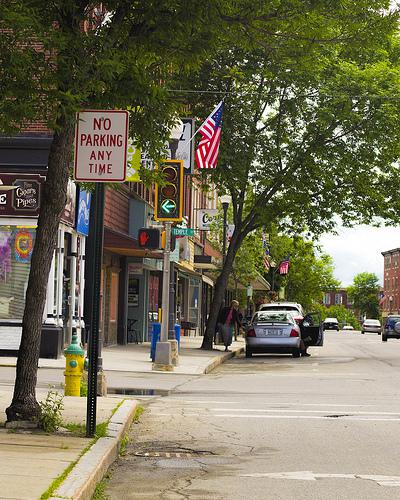Question: where was the picture taken?
Choices:
A. Under water.
B. Australia.
C. In a small town.
D. Paris.
Answer with the letter. Answer: C Question: what time of day is it?
Choices:
A. Lunch time.
B. Afternoon.
C. 4 o'clock.
D. Twilight.
Answer with the letter. Answer: B Question: what is lit up on the stop light?
Choices:
A. Red.
B. A green arrow.
C. Green.
D. Orange.
Answer with the letter. Answer: B Question: what does the sign say?
Choices:
A. No parking anytime.
B. Don't tread on me.
C. Caution.
D. Speed limit 75.
Answer with the letter. Answer: A Question: how many flags are hanging on the left side of the street?
Choices:
A. Four.
B. Three.
C. Five.
D. Six.
Answer with the letter. Answer: B Question: what is hanging over the car?
Choices:
A. Her arm.
B. A flag.
C. A rope.
D. A tree.
Answer with the letter. Answer: D 